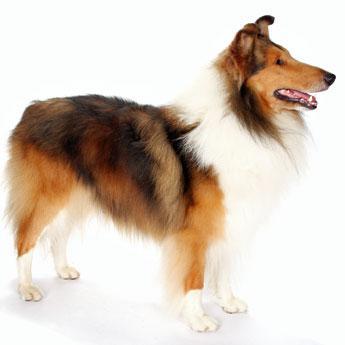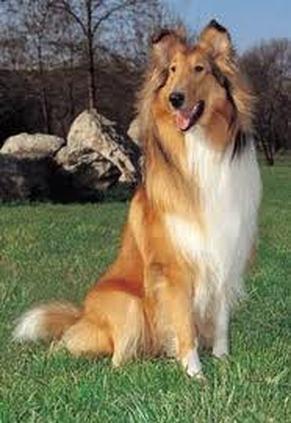The first image is the image on the left, the second image is the image on the right. Considering the images on both sides, is "The right image shows a collie posed on green grass." valid? Answer yes or no. Yes. 